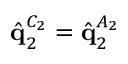Convert formula to latex. <formula><loc_0><loc_0><loc_500><loc_500>\hat { q } _ { 2 } ^ { C _ { 2 } } = \hat { q } _ { 2 } ^ { A _ { 2 } }</formula> 